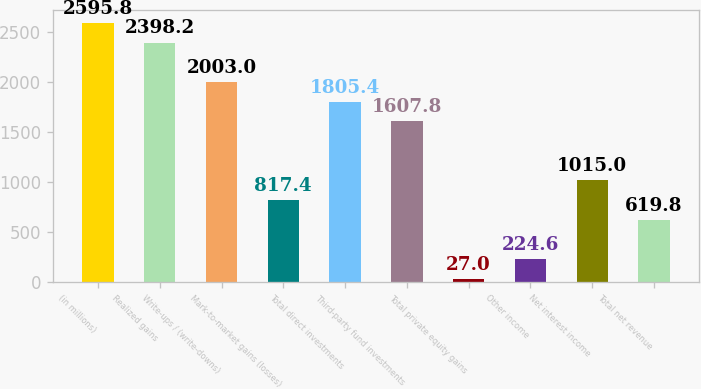Convert chart to OTSL. <chart><loc_0><loc_0><loc_500><loc_500><bar_chart><fcel>(in millions)<fcel>Realized gains<fcel>Write-ups / (write-downs)<fcel>Mark-to-market gains (losses)<fcel>Total direct investments<fcel>Third-party fund investments<fcel>Total private equity gains<fcel>Other income<fcel>Net interest income<fcel>Total net revenue<nl><fcel>2595.8<fcel>2398.2<fcel>2003<fcel>817.4<fcel>1805.4<fcel>1607.8<fcel>27<fcel>224.6<fcel>1015<fcel>619.8<nl></chart> 